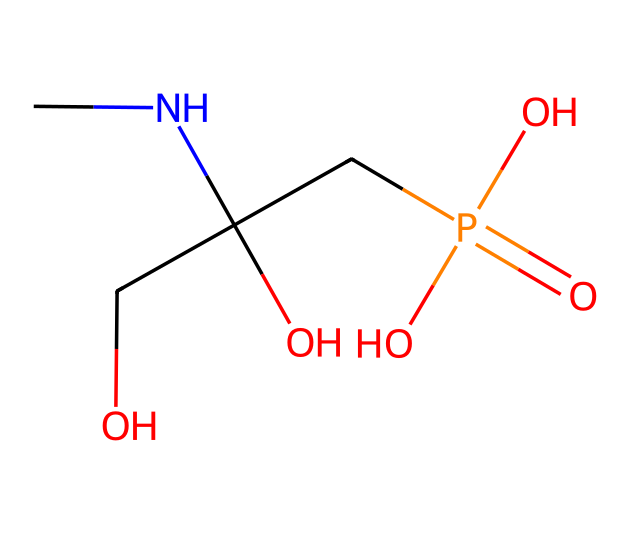What is the primary functional group present in glyphosate? The chemical structure of glyphosate contains a carboxylic acid functional group, as indicated by the presence of the -COOH group in its structure.
Answer: carboxylic acid How many nitrogen atoms are in the glyphosate structure? By analyzing the structure, there is one nitrogen atom present in glyphosate, as indicated by the "N" in the SMILES representation.
Answer: one What type of herbicide is glyphosate considered? Glyphosate is classified as a non-selective herbicide, meaning it targets a wide variety of plants, both grasses and broadleaf weeds, as indicated by its chemical properties and function.
Answer: non-selective What is the total number of carbon atoms in glyphosate? The SMILES representation shows that glyphosate contains three carbon atoms, which are visually identifiable in the structure.
Answer: three Does glyphosate have any phosphorus in its structure? Yes, glyphosate contains one phosphorus atom, as evidenced by the "P" in the SMILES notation which represents the phosphate group.
Answer: one Which part of glyphosate is responsible for its action as a herbicide? The primary action of glyphosate as a herbicide is due to the presence of the amino acid sequence that disrupts shikimic acid pathway enzymes, which is indicated by the presence of nitrogen and carbon frameworks in its structure.
Answer: amino acid sequence How does glyphosate interact with plants? Glyphosate inhibits a specific enzyme pathway (the shikimic acid pathway), preventing plants from synthesizing essential aromatic amino acids, resulting in plant death. This effect is derived from the overall design of the glyphosate molecule as a phosphonic acid derivative.
Answer: inhibits enzyme pathway 